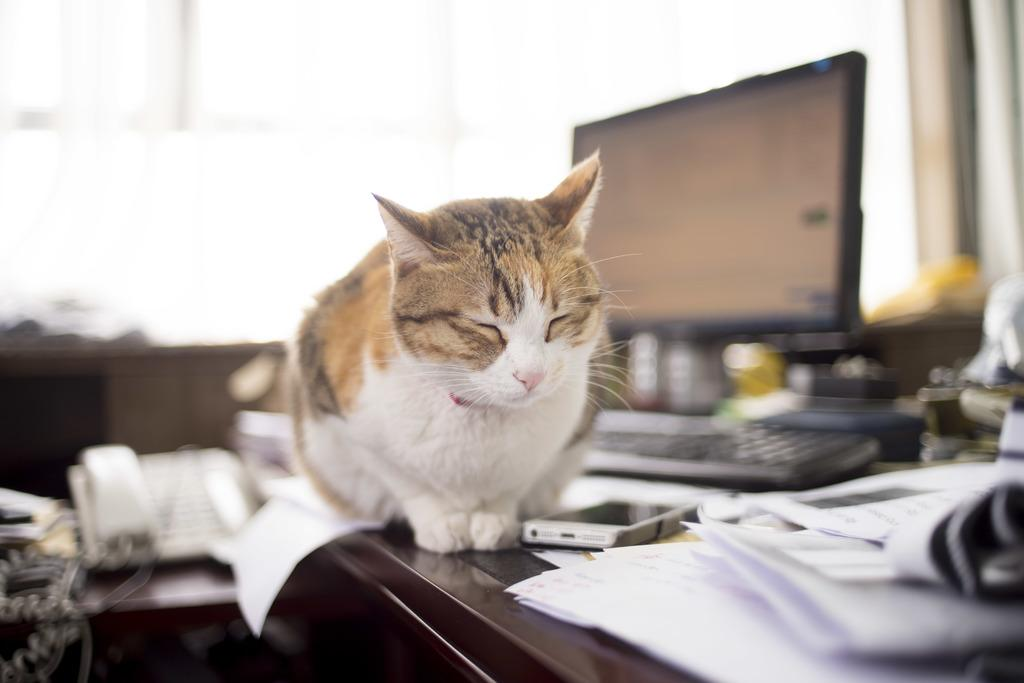What type of animal can be seen in the image? There is a cat in the image. What electronic device is present in the image? There is a mobile in the image. What is the primary input device in the image? There is a keyboard in the image. What is the primary output device in the image? There is a monitor in the image. What communication device is present in the image? There is a telephone in the image. What type of stationery items are present in the image? There are papers in the image. Can you describe the unspecified objects in the image? The unspecified objects in the image are not described in the provided facts. How would you describe the background of the image? The background of the image is blurry. What channel is the cat watching on the television in the image? There is no television present in the image, only a monitor. How many fingers does the cat have on its front paw in the image? The number of fingers on the cat's paw is not visible or mentioned in the provided facts. 